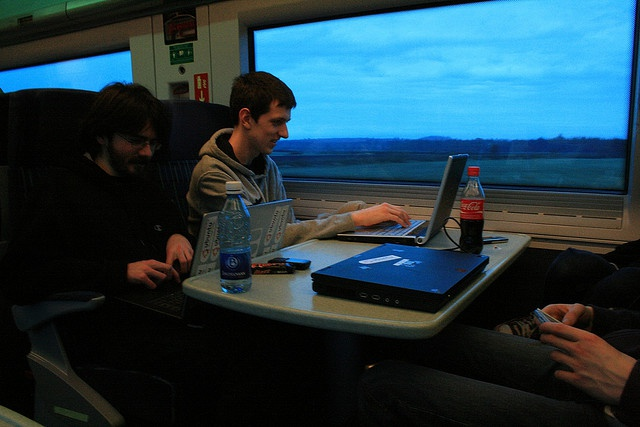Describe the objects in this image and their specific colors. I can see people in darkgreen, black, maroon, and brown tones, people in darkgreen, black, maroon, and brown tones, people in darkgreen, black, gray, and maroon tones, dining table in darkgreen, black, gray, and olive tones, and people in darkgreen, black, maroon, gray, and brown tones in this image. 